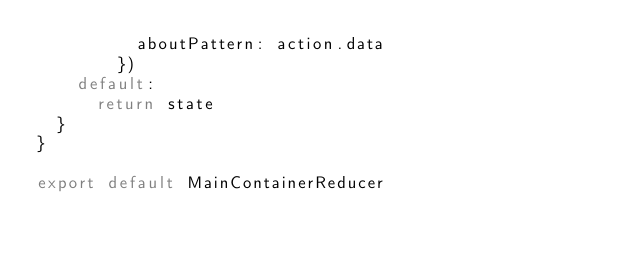<code> <loc_0><loc_0><loc_500><loc_500><_JavaScript_>      	  aboutPattern: action.data
        })
    default:
      return state
  }
}

export default MainContainerReducer</code> 